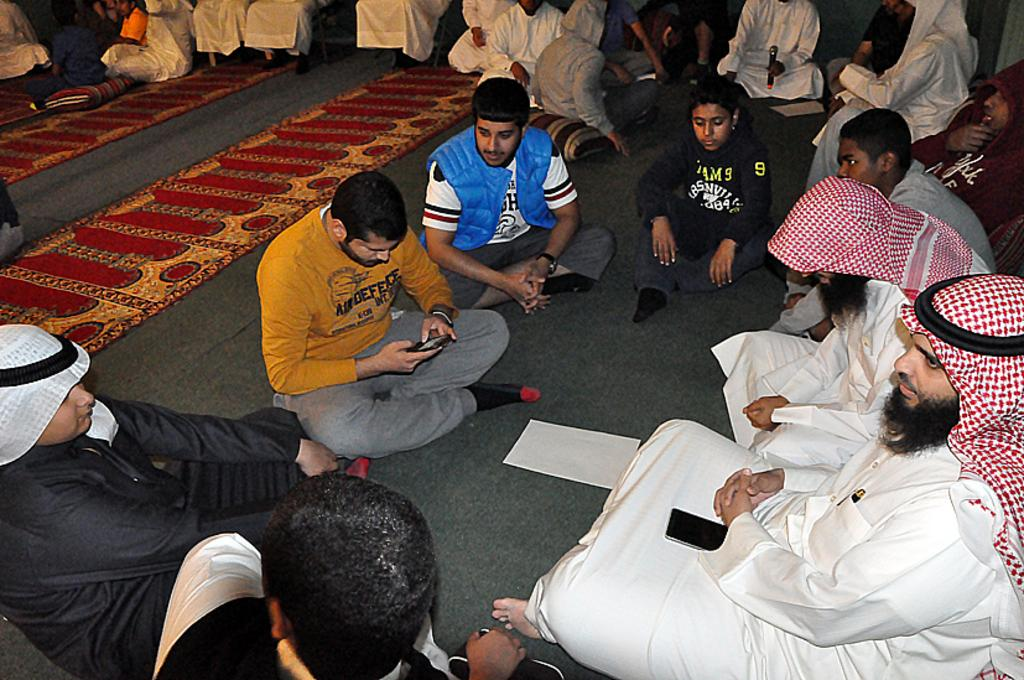What is the main subject in the image? There is a person's statue in the image. Can you describe the woman's position in the image? There is a woman sitting on the floor in the image. What else can be seen in the image besides the statue and the woman? There is another statue at the right side of the image. What can be seen in the background of the image? There are trees in the background of the image. What type of poison is the woman using to shake the trees in the image? There is no poison or shaking of trees in the image. The woman is sitting on the floor, and the trees are in the background. 